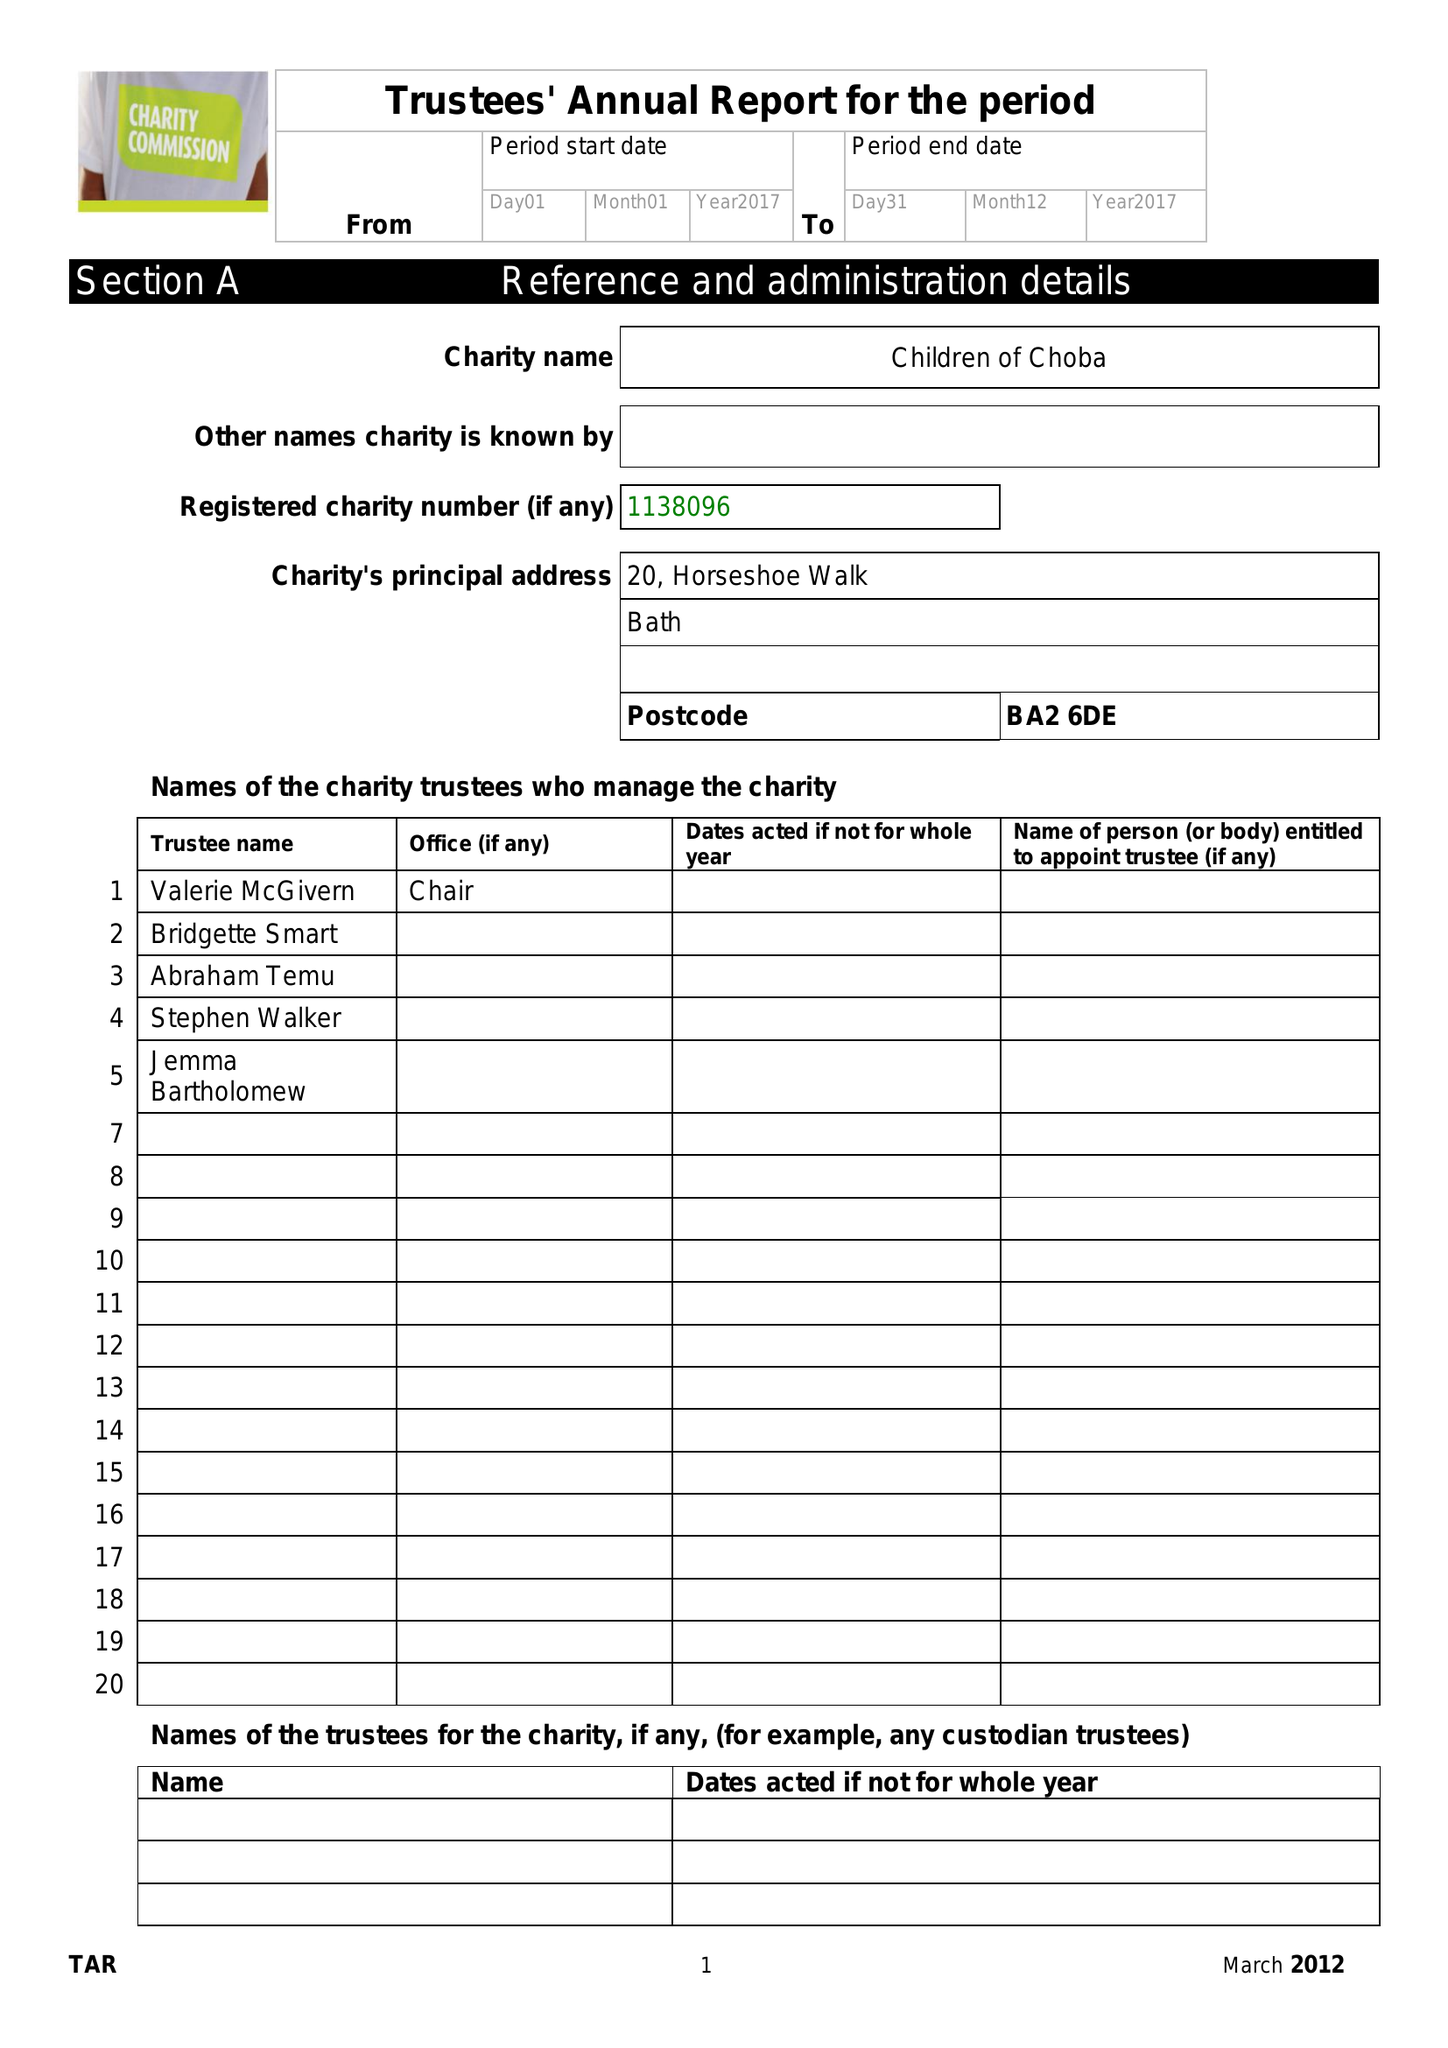What is the value for the address__street_line?
Answer the question using a single word or phrase. 20 HORSESHOE WALK 